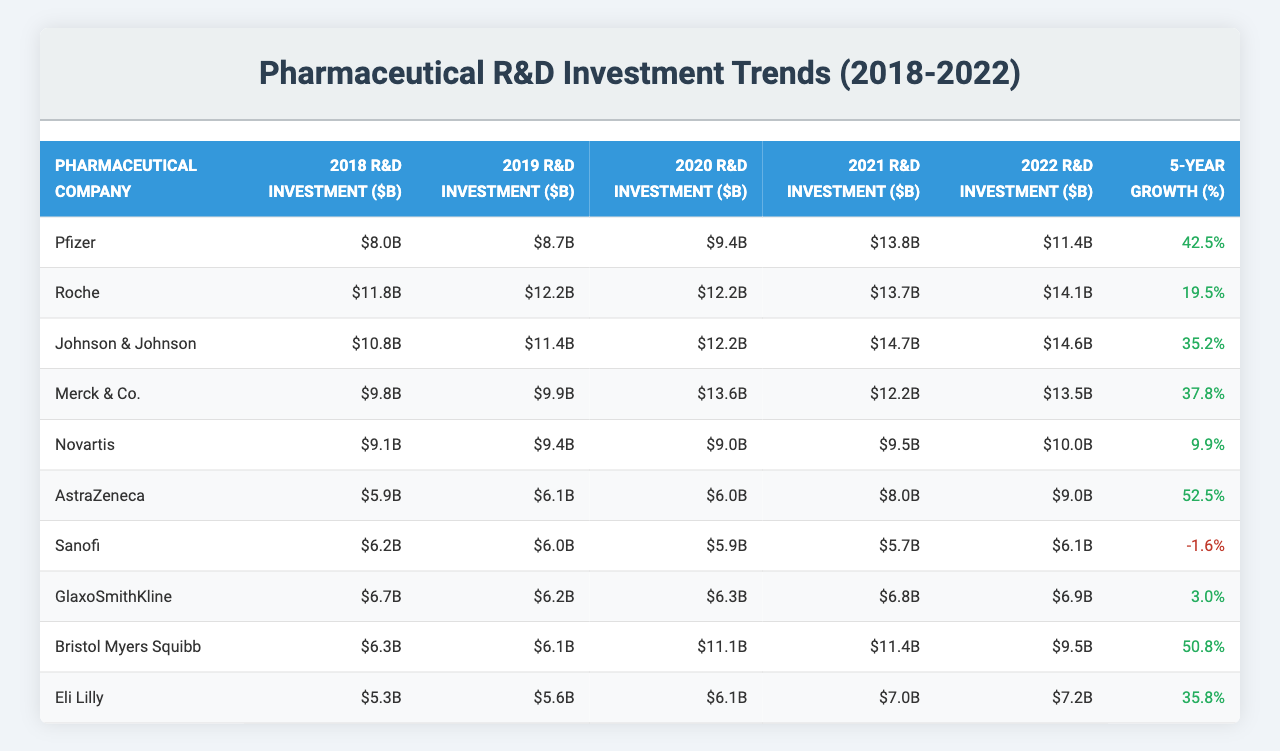What was the R&D investment of Pfizer in 2021? Pfizer's R&D investment in 2021 is listed as $13.8 billion in the table.
Answer: $13.8 billion Which company had the highest R&D investment in 2022? According to the table, Roche had the highest R&D investment in 2022, totaling $14.1 billion.
Answer: Roche What is the percentage growth of R&D investment for AstraZeneca over the past 5 years? AstraZeneca's 5-Year Growth percentage is 52.5%, as indicated in the last column of the table.
Answer: 52.5% Did Sanofi's R&D investment increase or decrease from 2018 to 2022? By comparing the figures, Sanofi's investments decreased from $6.2 billion in 2018 to $6.1 billion in 2022, indicating a decline.
Answer: Decrease What is the average R&D investment of Johnson & Johnson over the 5 years? The average is calculated by summing Johnson & Johnson's investments: (10.8 + 11.4 + 12.2 + 14.7 + 14.6) = 63.7 billion, and dividing by 5 gives 63.7 / 5 = 12.74 billion.
Answer: $12.74 billion Which company shows a negative growth in R&D investment, and what is the percentage? From the table, Sanofi shows a negative growth of -1.6%.
Answer: Sanofi, -1.6% How much more did Bristol Myers Squibb invest in R&D in 2020 compared to 2019? Bristol Myers Squibb invested $11.1 billion in 2020 and $6.1 billion in 2019. The difference is $11.1 - $6.1 = $5 billion.
Answer: $5 billion Which company has the smallest R&D investment in the final year, and what is the amount? Eli Lilly had the smallest R&D investment in 2022, amounting to $7.2 billion.
Answer: Eli Lilly, $7.2 billion What is the total R&D investment made by Merck & Co. from 2018 to 2022? Summing Merck & Co.’s investments gives: (9.8 + 9.9 + 13.6 + 12.2 + 13.5) = 68.9 billion.
Answer: $68.9 billion Which companies had over $10 billion in R&D investments in 2021? The companies with over $10 billion in 2021 are Pfizer ($13.8B), Roche ($13.7B), and Johnson & Johnson ($14.7B).
Answer: Pfizer, Roche, Johnson & Johnson How does Novartis' R&D investment in 2022 compare to AstraZeneca's investment in the same year? Novartis invested $10.0 billion while AstraZeneca invested $9.0 billion in 2022. Novartis invested more.
Answer: Novartis invested more 